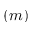Convert formula to latex. <formula><loc_0><loc_0><loc_500><loc_500>( m )</formula> 